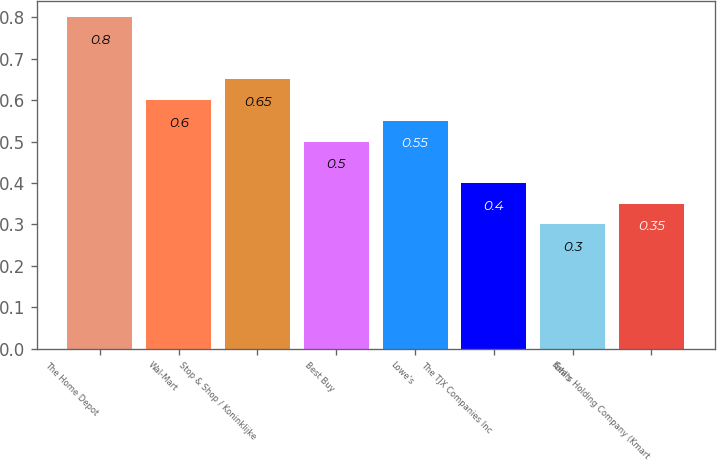<chart> <loc_0><loc_0><loc_500><loc_500><bar_chart><fcel>The Home Depot<fcel>Wal-Mart<fcel>Stop & Shop / Koninklijke<fcel>Best Buy<fcel>Lowe's<fcel>The TJX Companies Inc<fcel>Kohl's<fcel>Sears Holding Company (Kmart<nl><fcel>0.8<fcel>0.6<fcel>0.65<fcel>0.5<fcel>0.55<fcel>0.4<fcel>0.3<fcel>0.35<nl></chart> 